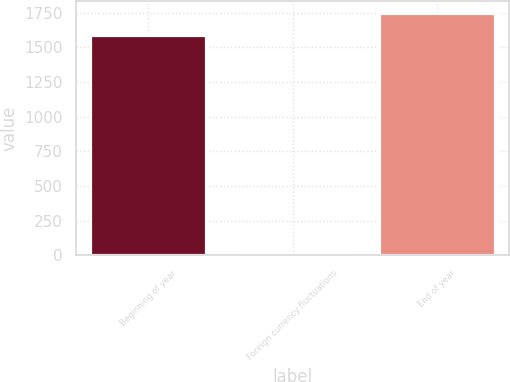Convert chart to OTSL. <chart><loc_0><loc_0><loc_500><loc_500><bar_chart><fcel>Beginning of year<fcel>Foreign currency fluctuations<fcel>End of year<nl><fcel>1587.7<fcel>18.4<fcel>1746.69<nl></chart> 